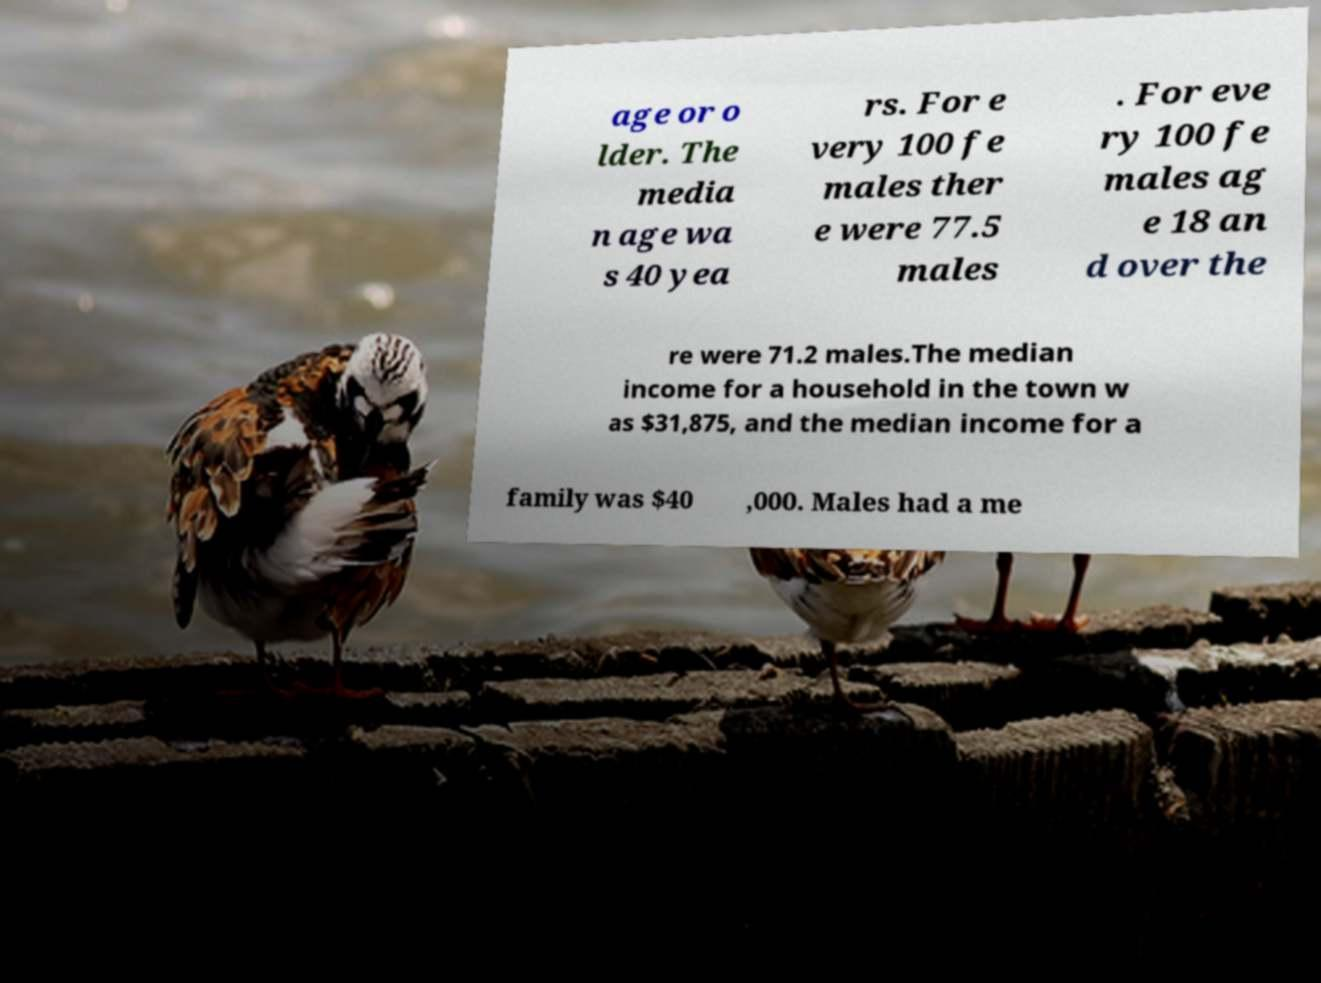Could you assist in decoding the text presented in this image and type it out clearly? age or o lder. The media n age wa s 40 yea rs. For e very 100 fe males ther e were 77.5 males . For eve ry 100 fe males ag e 18 an d over the re were 71.2 males.The median income for a household in the town w as $31,875, and the median income for a family was $40 ,000. Males had a me 